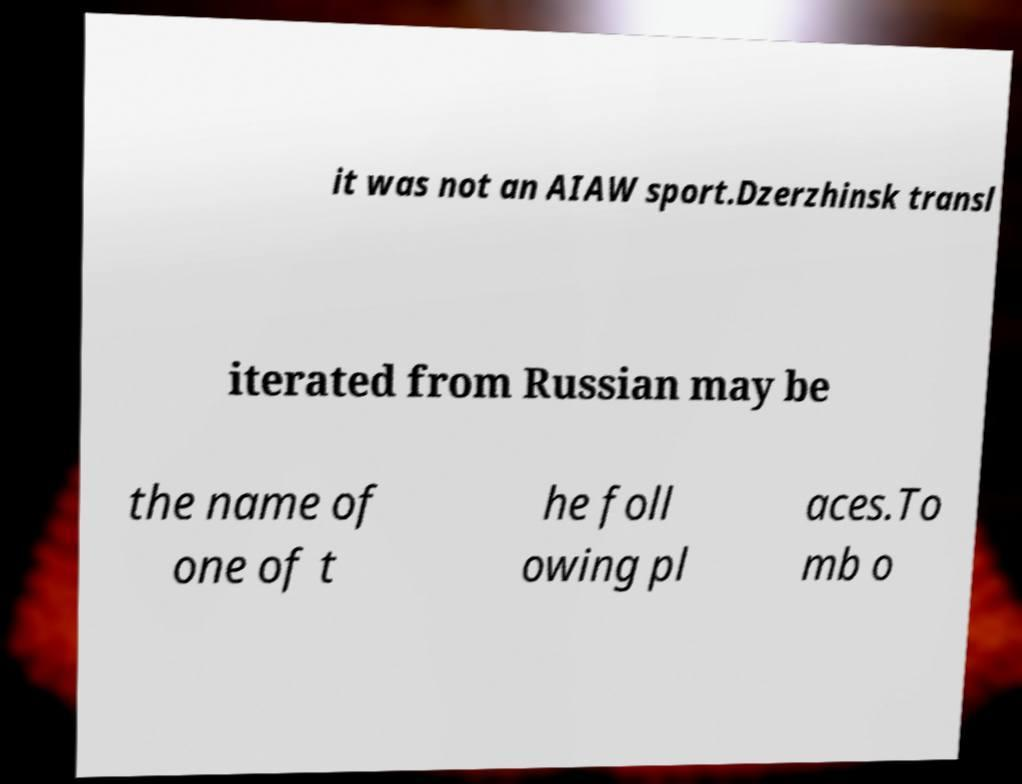I need the written content from this picture converted into text. Can you do that? it was not an AIAW sport.Dzerzhinsk transl iterated from Russian may be the name of one of t he foll owing pl aces.To mb o 